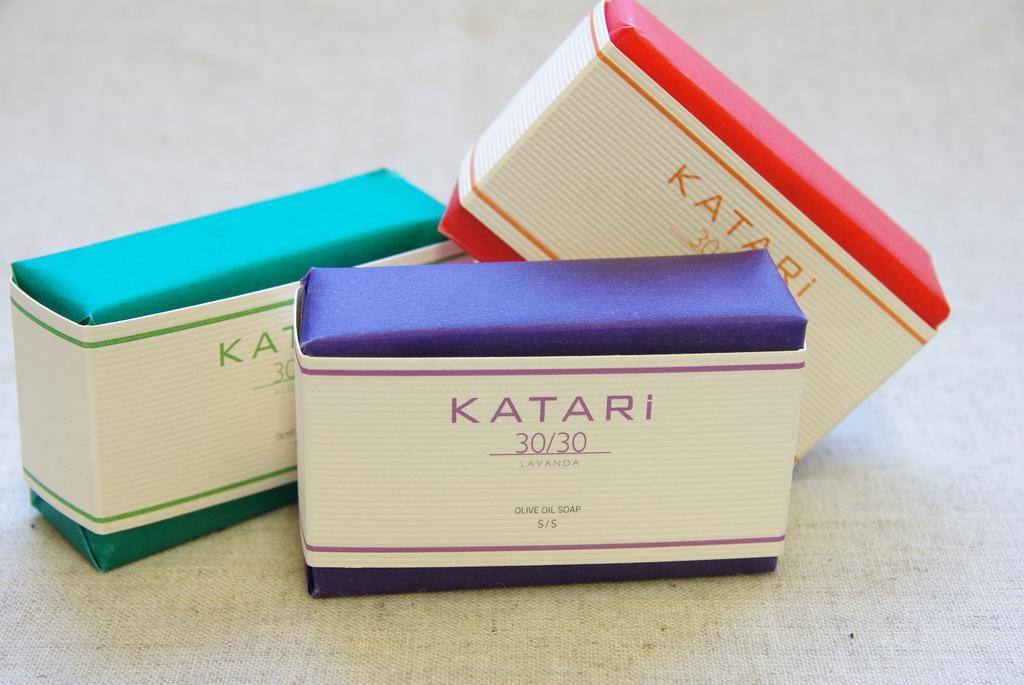<image>
Offer a succinct explanation of the picture presented. Three boxes of Katari 30/30 soap next to each other 